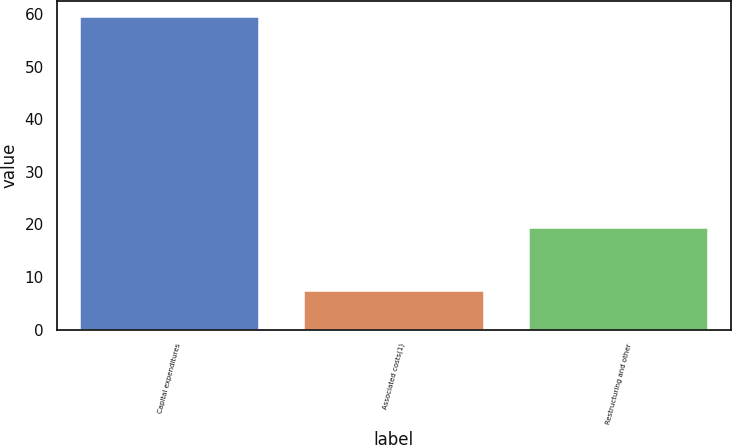Convert chart. <chart><loc_0><loc_0><loc_500><loc_500><bar_chart><fcel>Capital expenditures<fcel>Associated costs(1)<fcel>Restructuring and other<nl><fcel>59.5<fcel>7.4<fcel>19.3<nl></chart> 